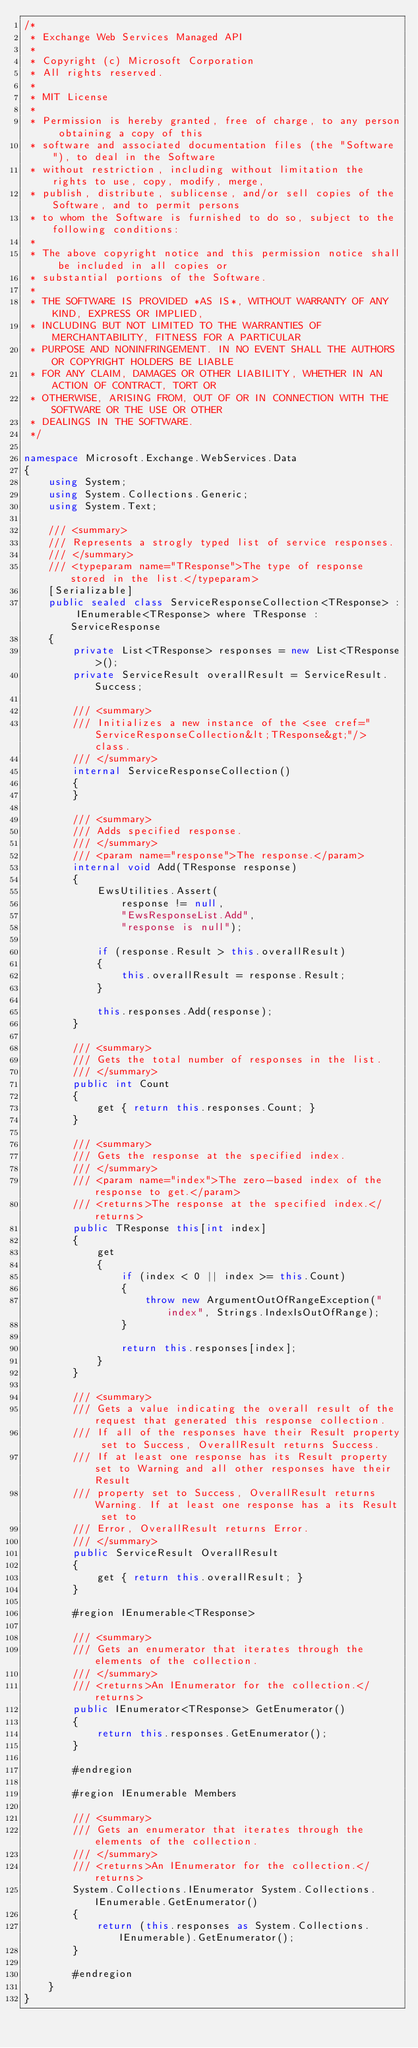Convert code to text. <code><loc_0><loc_0><loc_500><loc_500><_C#_>/*
 * Exchange Web Services Managed API
 *
 * Copyright (c) Microsoft Corporation
 * All rights reserved.
 *
 * MIT License
 *
 * Permission is hereby granted, free of charge, to any person obtaining a copy of this
 * software and associated documentation files (the "Software"), to deal in the Software
 * without restriction, including without limitation the rights to use, copy, modify, merge,
 * publish, distribute, sublicense, and/or sell copies of the Software, and to permit persons
 * to whom the Software is furnished to do so, subject to the following conditions:
 *
 * The above copyright notice and this permission notice shall be included in all copies or
 * substantial portions of the Software.
 *
 * THE SOFTWARE IS PROVIDED *AS IS*, WITHOUT WARRANTY OF ANY KIND, EXPRESS OR IMPLIED,
 * INCLUDING BUT NOT LIMITED TO THE WARRANTIES OF MERCHANTABILITY, FITNESS FOR A PARTICULAR
 * PURPOSE AND NONINFRINGEMENT. IN NO EVENT SHALL THE AUTHORS OR COPYRIGHT HOLDERS BE LIABLE
 * FOR ANY CLAIM, DAMAGES OR OTHER LIABILITY, WHETHER IN AN ACTION OF CONTRACT, TORT OR
 * OTHERWISE, ARISING FROM, OUT OF OR IN CONNECTION WITH THE SOFTWARE OR THE USE OR OTHER
 * DEALINGS IN THE SOFTWARE.
 */

namespace Microsoft.Exchange.WebServices.Data
{
    using System;
    using System.Collections.Generic;
    using System.Text;

    /// <summary>
    /// Represents a strogly typed list of service responses.
    /// </summary>
    /// <typeparam name="TResponse">The type of response stored in the list.</typeparam>
    [Serializable]
    public sealed class ServiceResponseCollection<TResponse> : IEnumerable<TResponse> where TResponse : ServiceResponse
    {
        private List<TResponse> responses = new List<TResponse>();
        private ServiceResult overallResult = ServiceResult.Success;

        /// <summary>
        /// Initializes a new instance of the <see cref="ServiceResponseCollection&lt;TResponse&gt;"/> class.
        /// </summary>
        internal ServiceResponseCollection()
        {
        }

        /// <summary>
        /// Adds specified response.
        /// </summary>
        /// <param name="response">The response.</param>
        internal void Add(TResponse response)
        {
            EwsUtilities.Assert(
                response != null,
                "EwsResponseList.Add",
                "response is null");

            if (response.Result > this.overallResult)
            {
                this.overallResult = response.Result;
            }

            this.responses.Add(response);
        }

        /// <summary>
        /// Gets the total number of responses in the list.
        /// </summary>
        public int Count
        {
            get { return this.responses.Count; }
        }

        /// <summary>
        /// Gets the response at the specified index.
        /// </summary>
        /// <param name="index">The zero-based index of the response to get.</param>
        /// <returns>The response at the specified index.</returns>
        public TResponse this[int index]
        {
            get
            {
                if (index < 0 || index >= this.Count)
                {
                    throw new ArgumentOutOfRangeException("index", Strings.IndexIsOutOfRange);
                }

                return this.responses[index];
            }
        }

        /// <summary>
        /// Gets a value indicating the overall result of the request that generated this response collection.
        /// If all of the responses have their Result property set to Success, OverallResult returns Success.
        /// If at least one response has its Result property set to Warning and all other responses have their Result
        /// property set to Success, OverallResult returns Warning. If at least one response has a its Result set to
        /// Error, OverallResult returns Error.
        /// </summary>
        public ServiceResult OverallResult
        {
            get { return this.overallResult; }
        }

        #region IEnumerable<TResponse>

        /// <summary>
        /// Gets an enumerator that iterates through the elements of the collection.
        /// </summary>
        /// <returns>An IEnumerator for the collection.</returns>
        public IEnumerator<TResponse> GetEnumerator()
        {
            return this.responses.GetEnumerator();
        }

        #endregion

        #region IEnumerable Members

        /// <summary>
        /// Gets an enumerator that iterates through the elements of the collection.
        /// </summary>
        /// <returns>An IEnumerator for the collection.</returns>
        System.Collections.IEnumerator System.Collections.IEnumerable.GetEnumerator()
        {
            return (this.responses as System.Collections.IEnumerable).GetEnumerator();
        }

        #endregion
    }
}</code> 